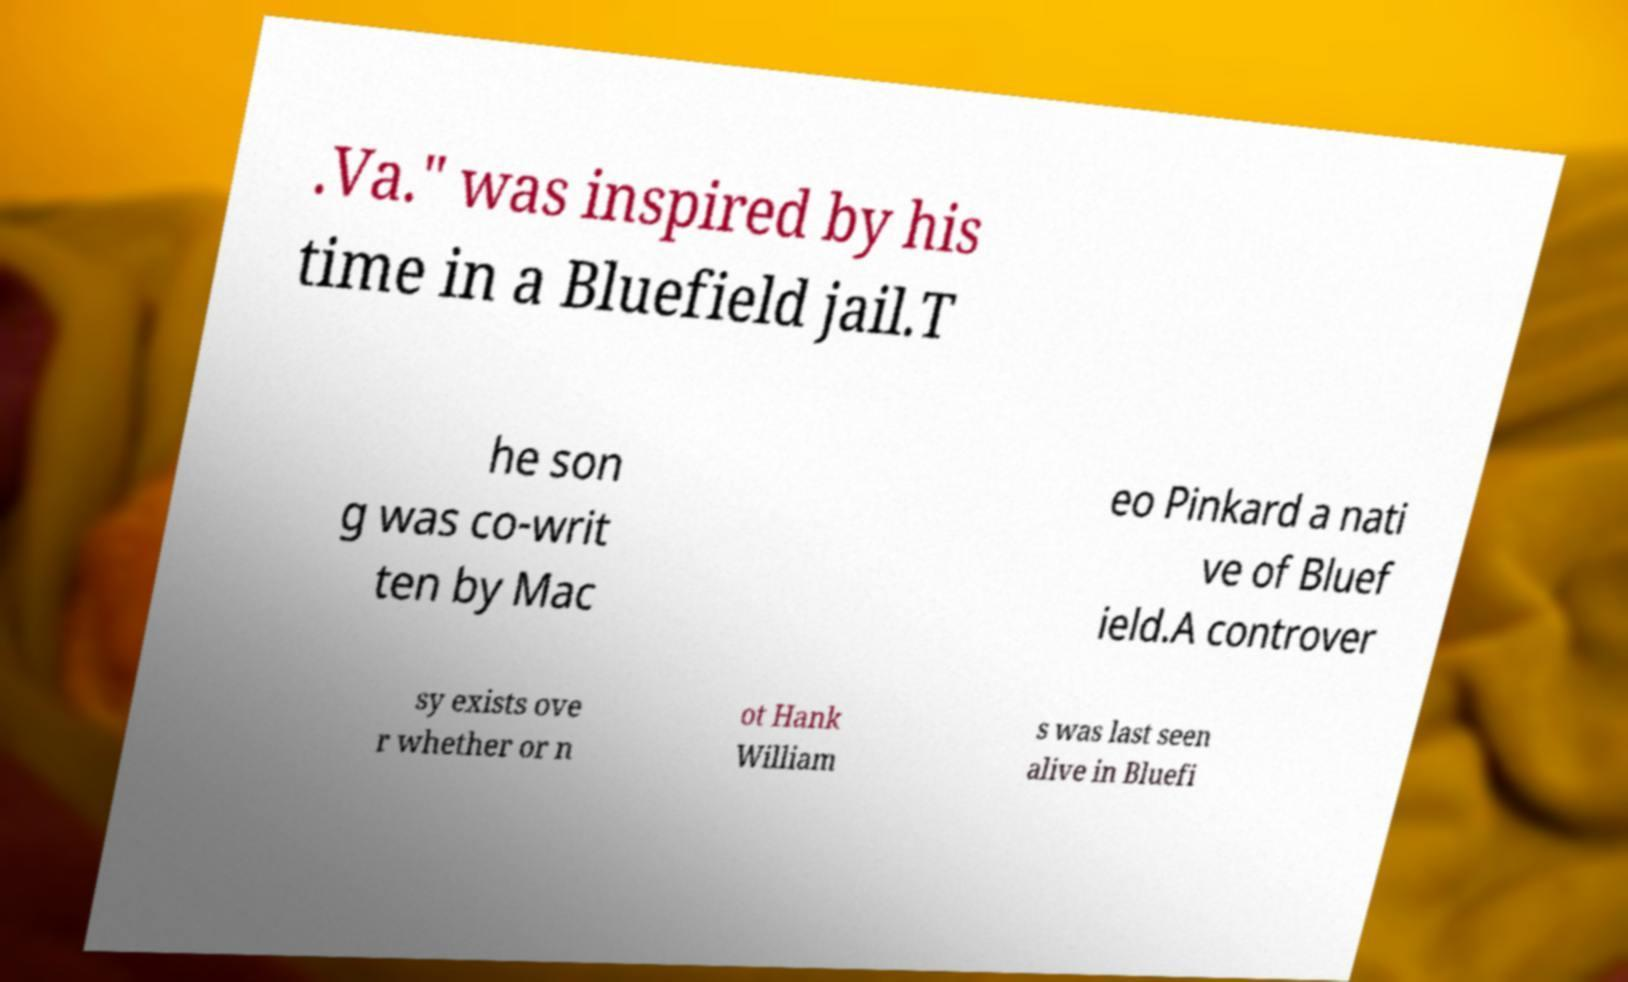Please identify and transcribe the text found in this image. .Va." was inspired by his time in a Bluefield jail.T he son g was co-writ ten by Mac eo Pinkard a nati ve of Bluef ield.A controver sy exists ove r whether or n ot Hank William s was last seen alive in Bluefi 